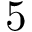Convert formula to latex. <formula><loc_0><loc_0><loc_500><loc_500>5</formula> 